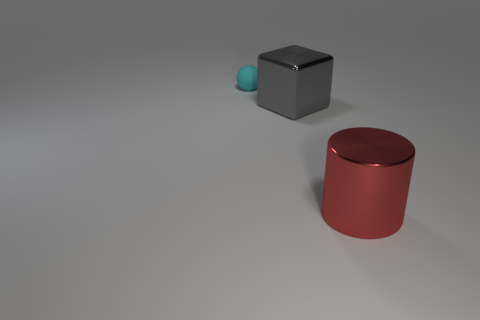Add 1 large brown metallic objects. How many objects exist? 4 Subtract 1 balls. How many balls are left? 0 Subtract all small green metallic cubes. Subtract all cyan objects. How many objects are left? 2 Add 1 red shiny cylinders. How many red shiny cylinders are left? 2 Add 3 large yellow objects. How many large yellow objects exist? 3 Subtract 0 cyan blocks. How many objects are left? 3 Subtract all cylinders. How many objects are left? 2 